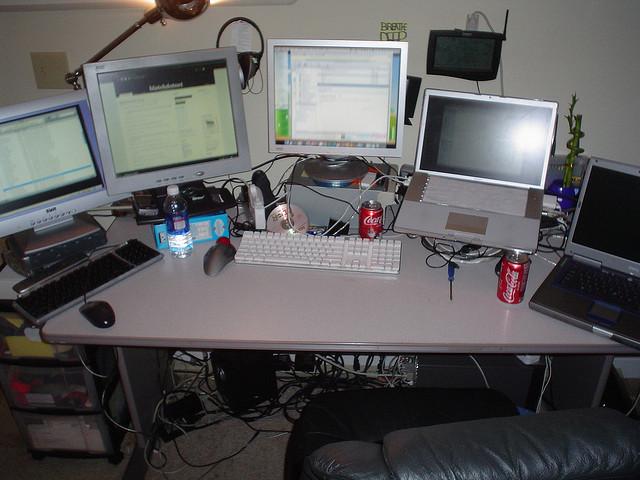Are all of the computer screens turned on?
Be succinct. No. What kind of cans are on the desk?
Quick response, please. Coca cola. How many drinks are on the desk?
Short answer required. 3. What side of the photo is the mouse on?
Keep it brief. Left. 